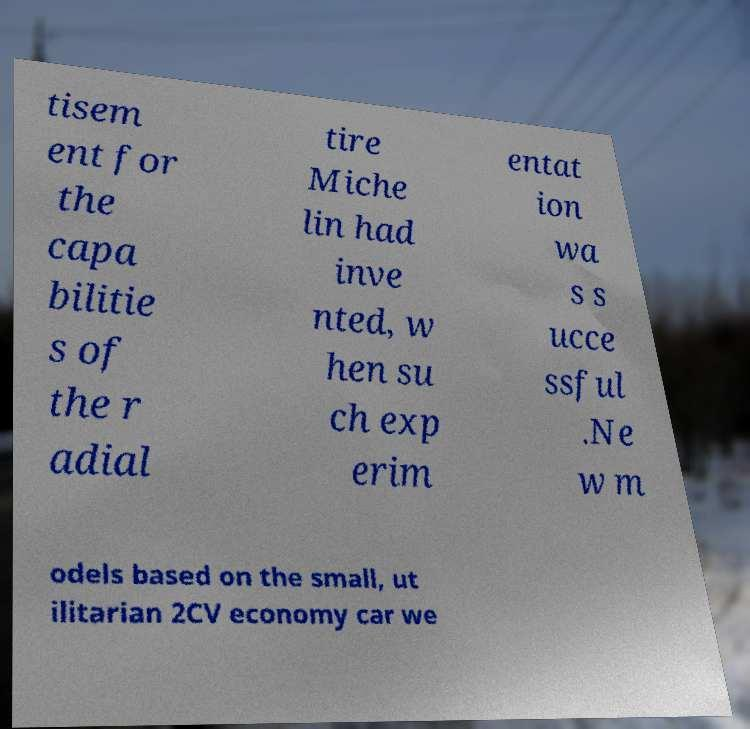I need the written content from this picture converted into text. Can you do that? tisem ent for the capa bilitie s of the r adial tire Miche lin had inve nted, w hen su ch exp erim entat ion wa s s ucce ssful .Ne w m odels based on the small, ut ilitarian 2CV economy car we 